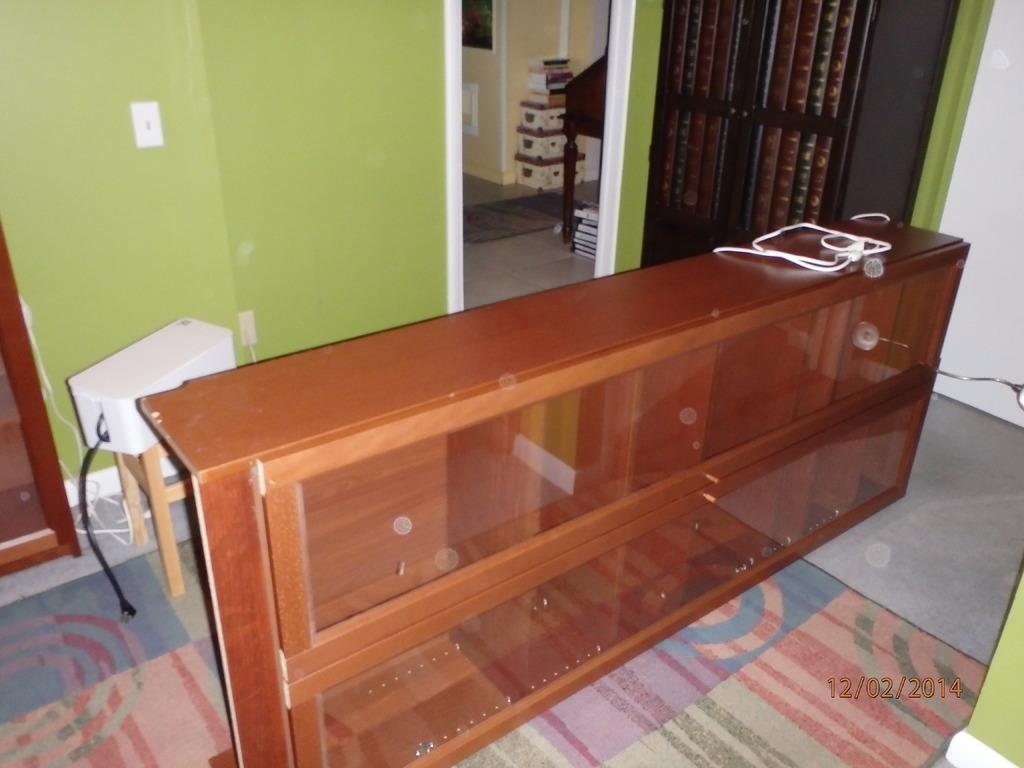What type of cupboard is visible in the image? There is a wooden cupboard with glass doors in the image. What is located behind the cupboard? There is a table behind the cupboard. What can be seen on the table? There are objects on the table. What is the background of the table? There is a wall behind the table. Is there any additional information about the image? The image has a watermark. What type of copper pots can be seen on the table in the image? There is no mention of copper pots in the image; the objects on the table are not specified. 